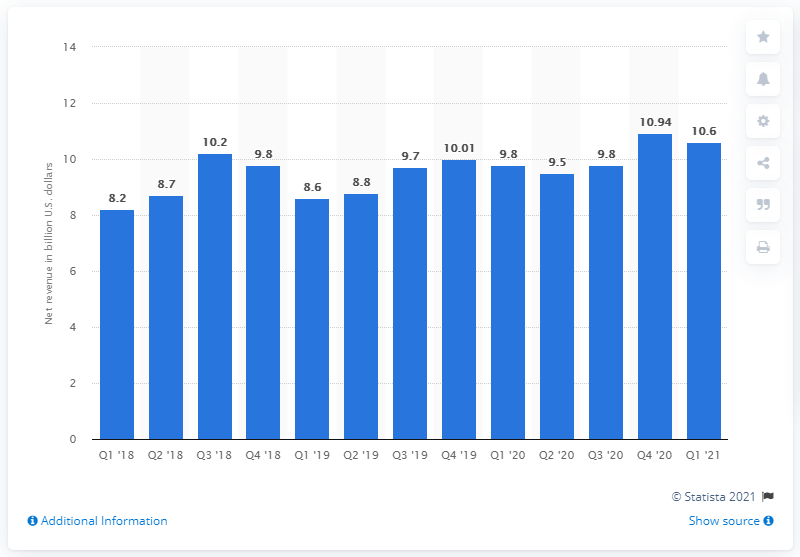Mention a couple of crucial points in this snapshot. Intel's CCG revenue in the first quarter of 2021 was $10.6 billion. In the first quarter of 2021, the CCG revenue was 9.8 million. 